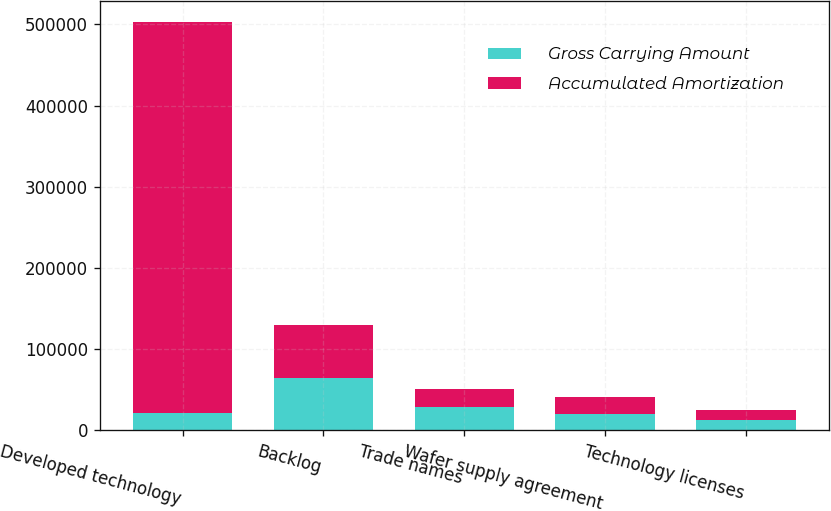Convert chart. <chart><loc_0><loc_0><loc_500><loc_500><stacked_bar_chart><ecel><fcel>Developed technology<fcel>Backlog<fcel>Trade names<fcel>Wafer supply agreement<fcel>Technology licenses<nl><fcel>Gross Carrying Amount<fcel>21912<fcel>65000<fcel>29353<fcel>20443<fcel>13346<nl><fcel>Accumulated Amortization<fcel>481441<fcel>65000<fcel>21912<fcel>20443<fcel>11711<nl></chart> 